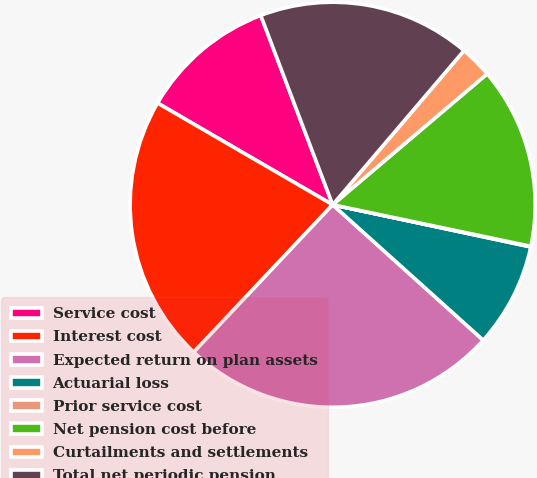Convert chart to OTSL. <chart><loc_0><loc_0><loc_500><loc_500><pie_chart><fcel>Service cost<fcel>Interest cost<fcel>Expected return on plan assets<fcel>Actuarial loss<fcel>Prior service cost<fcel>Net pension cost before<fcel>Curtailments and settlements<fcel>Total net periodic pension<nl><fcel>10.85%<fcel>21.35%<fcel>25.37%<fcel>8.32%<fcel>0.05%<fcel>14.48%<fcel>2.58%<fcel>17.01%<nl></chart> 